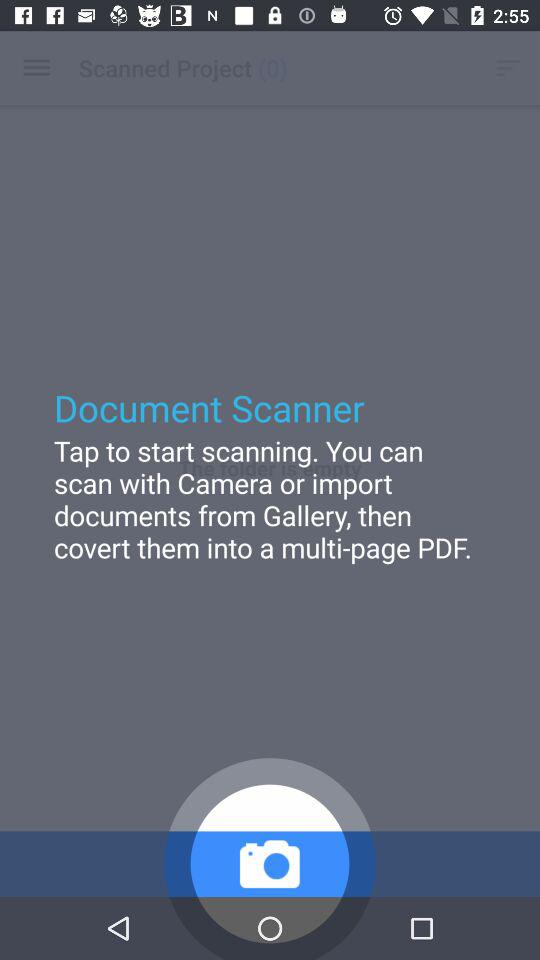What is the number of scanned projects? The number of scanned projects is 0. 